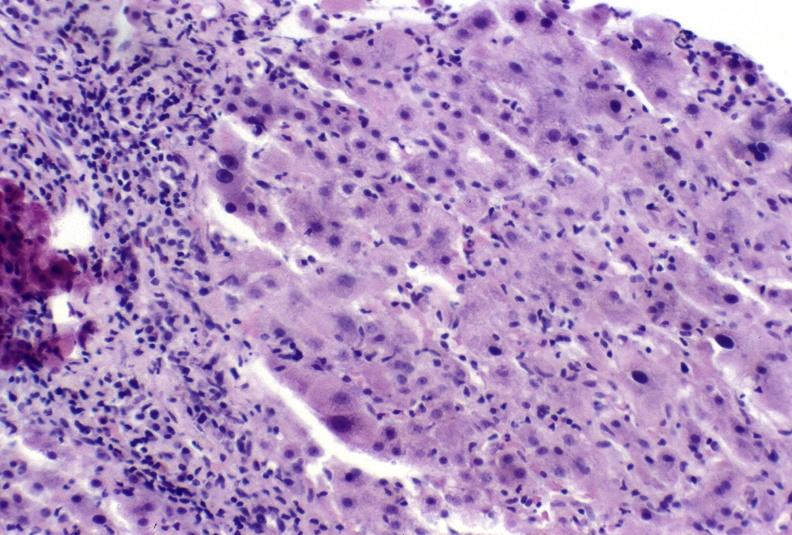s this image shows of smooth muscle cell with lipid in sarcoplasm and lipid present?
Answer the question using a single word or phrase. No 